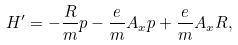<formula> <loc_0><loc_0><loc_500><loc_500>H ^ { \prime } = - \frac { R } { m } p - \frac { e } { m } A _ { x } p + \frac { e } { m } A _ { x } R ,</formula> 